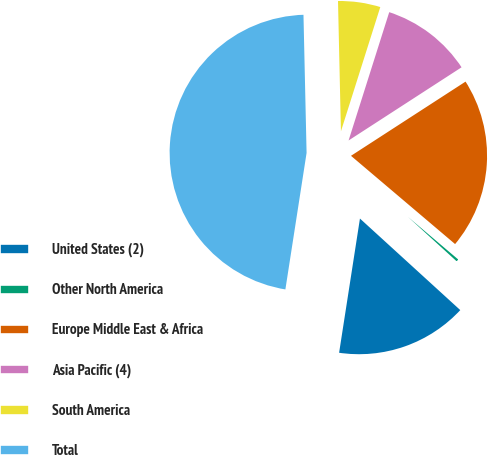<chart> <loc_0><loc_0><loc_500><loc_500><pie_chart><fcel>United States (2)<fcel>Other North America<fcel>Europe Middle East & Africa<fcel>Asia Pacific (4)<fcel>South America<fcel>Total<nl><fcel>15.68%<fcel>0.58%<fcel>20.34%<fcel>10.97%<fcel>5.24%<fcel>47.19%<nl></chart> 